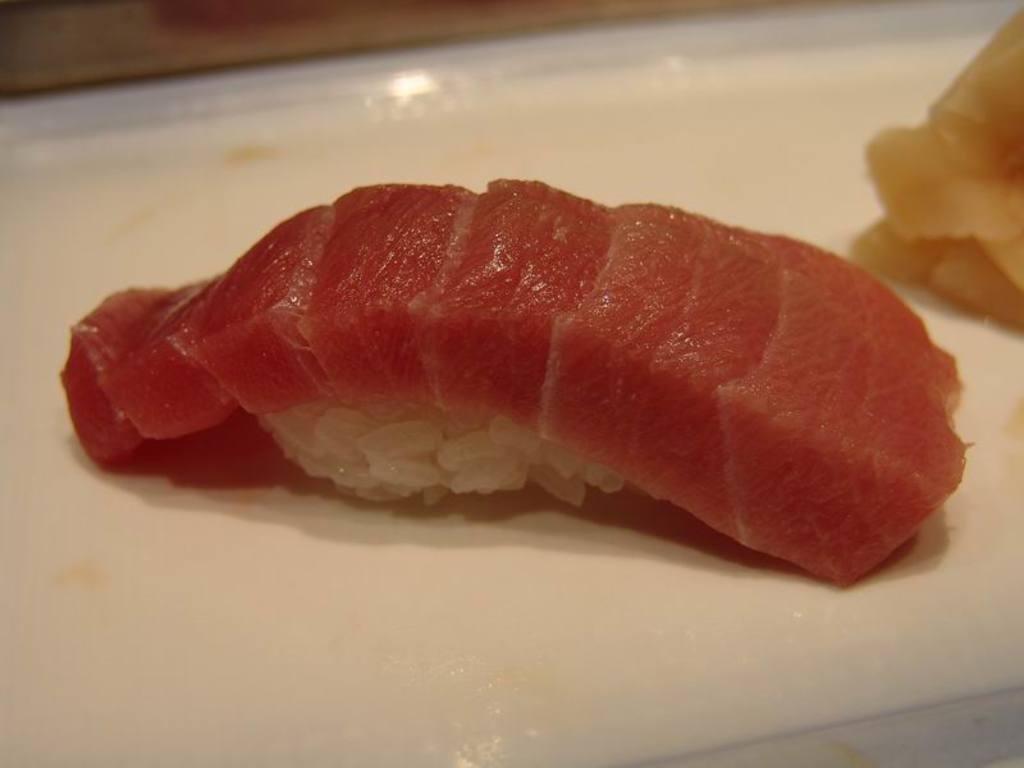How would you summarize this image in a sentence or two? In this image we can see a plate containing food. 